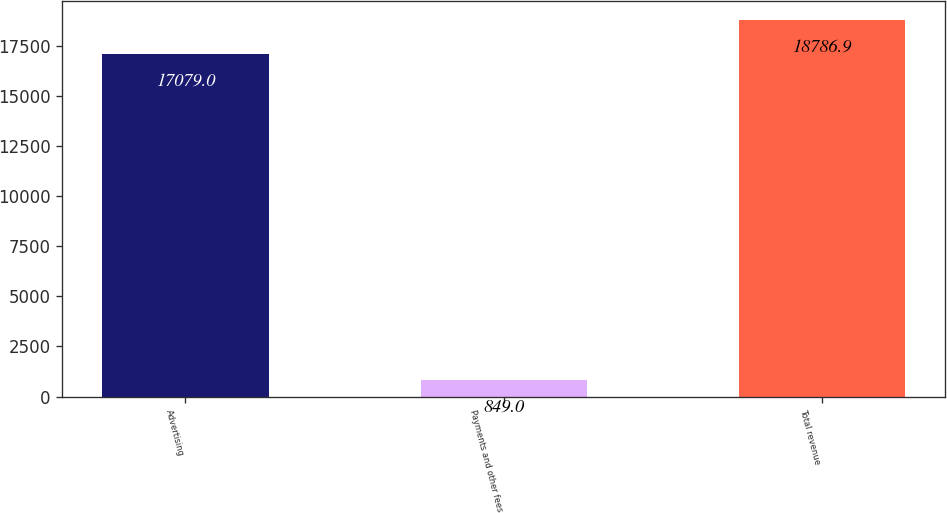<chart> <loc_0><loc_0><loc_500><loc_500><bar_chart><fcel>Advertising<fcel>Payments and other fees<fcel>Total revenue<nl><fcel>17079<fcel>849<fcel>18786.9<nl></chart> 